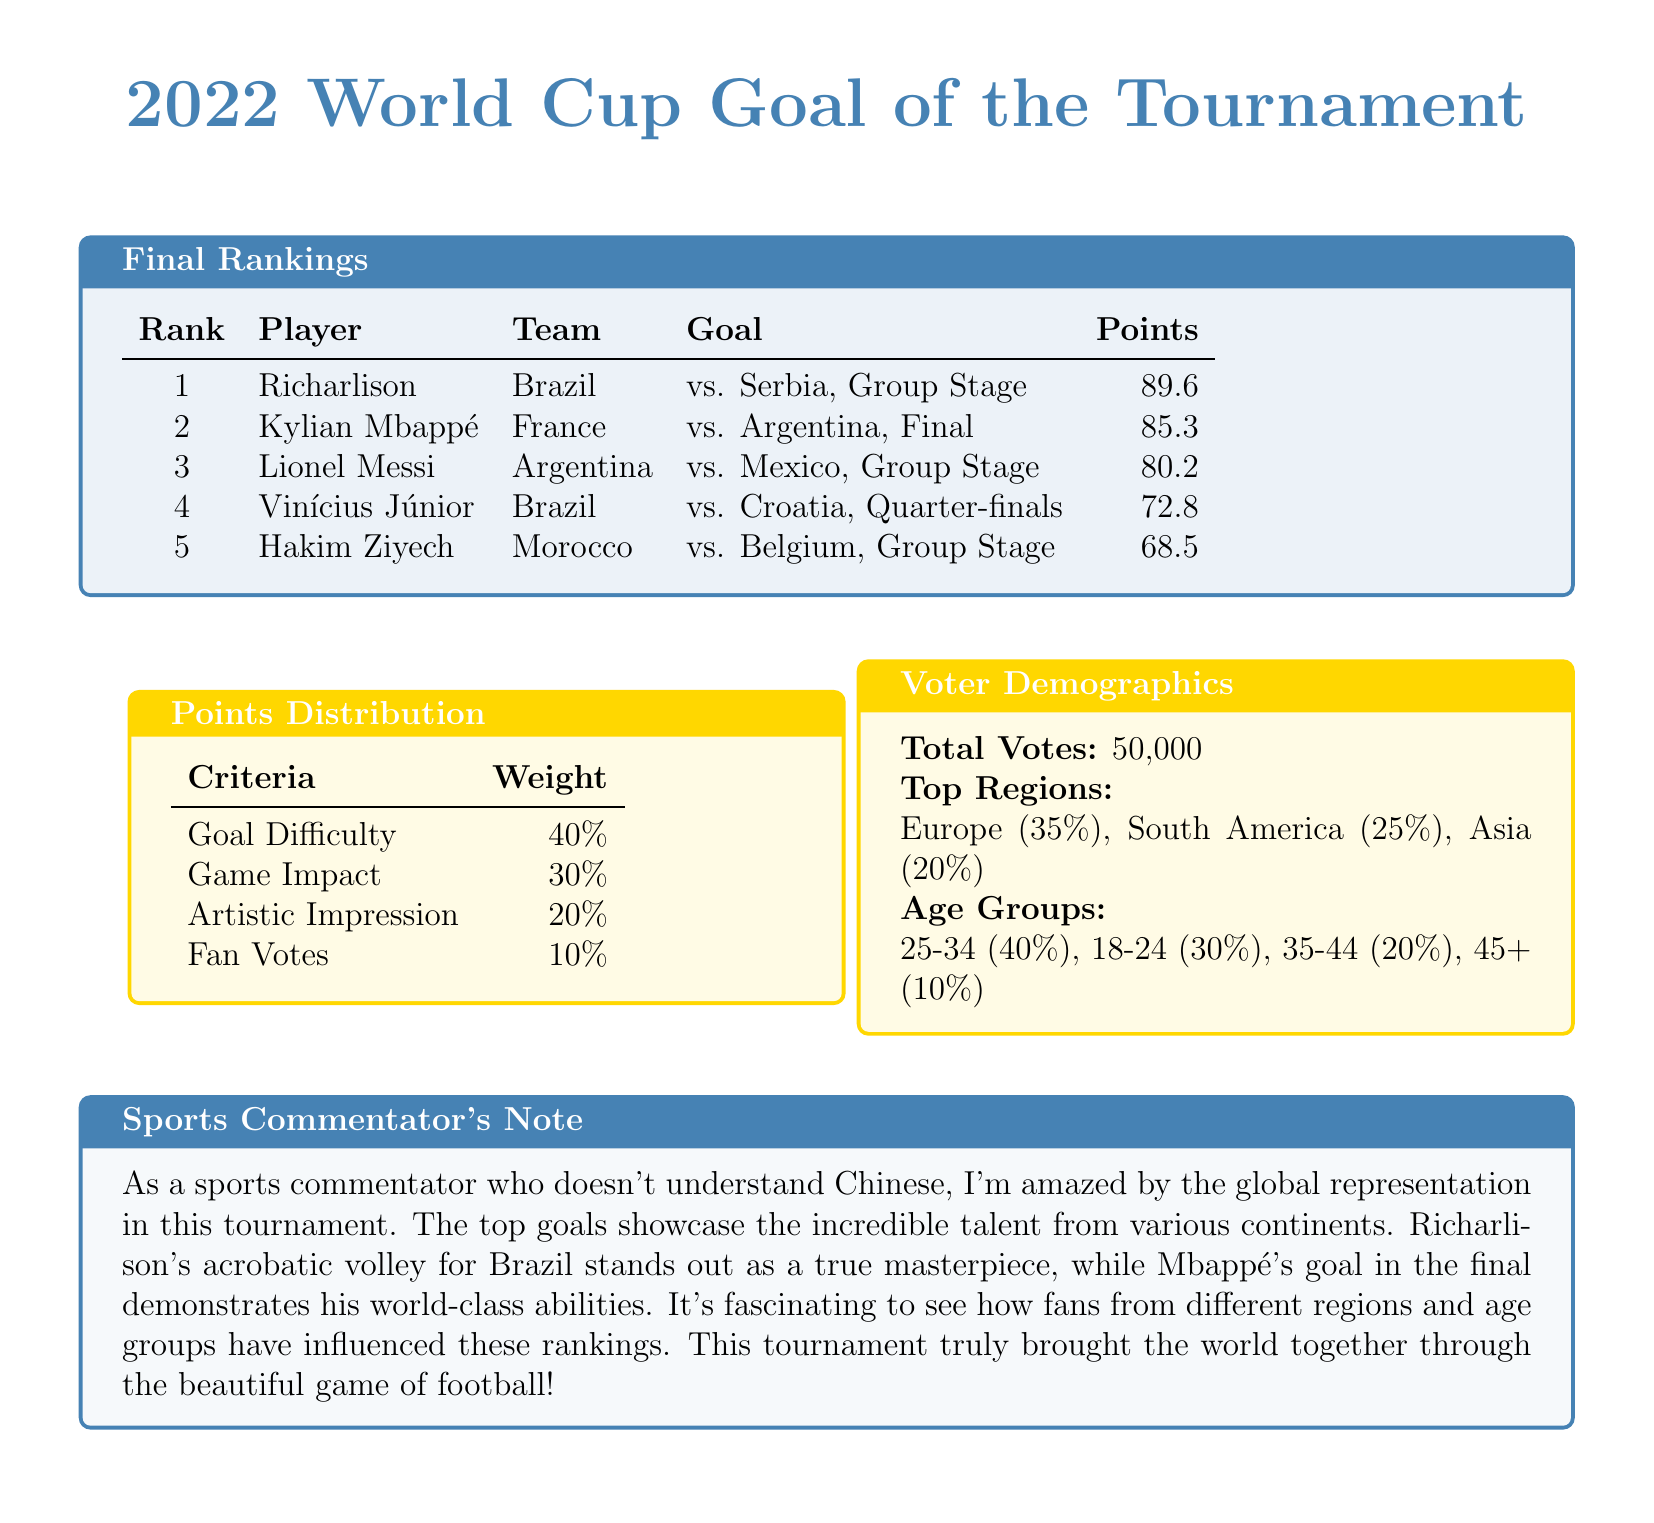what is the rank of Richarlison? Richarlison is listed first in the final rankings table, indicating his rank is number 1.
Answer: 1 how many total votes were cast? The document states that there were 50,000 total votes cast for the Goal of the Tournament.
Answer: 50,000 which player scored the highest points? The player with the highest points is Richarlison, with a score of 89.6.
Answer: Richarlison what percentage of votes came from Europe? The document indicates that 35% of the votes came from Europe.
Answer: 35% what is the weight of Game Impact in the points distribution? The weight allocated for Game Impact is clearly stated as 30%.
Answer: 30% who scored the goal for Argentina in the final? Kylian Mbappé scored the goal for France in the final against Argentina.
Answer: Kylian Mbappé what age group has the highest percentage of voters? The age group with the highest percentage of voters, as indicated in the demographics section, is 25-34.
Answer: 25-34 how many players are listed in the final rankings? The table indicates there are five players listed in the final rankings.
Answer: 5 which goal was scored by Hakim Ziyech? The document details that Hakim Ziyech scored against Belgium in the Group Stage.
Answer: vs. Belgium, Group Stage 